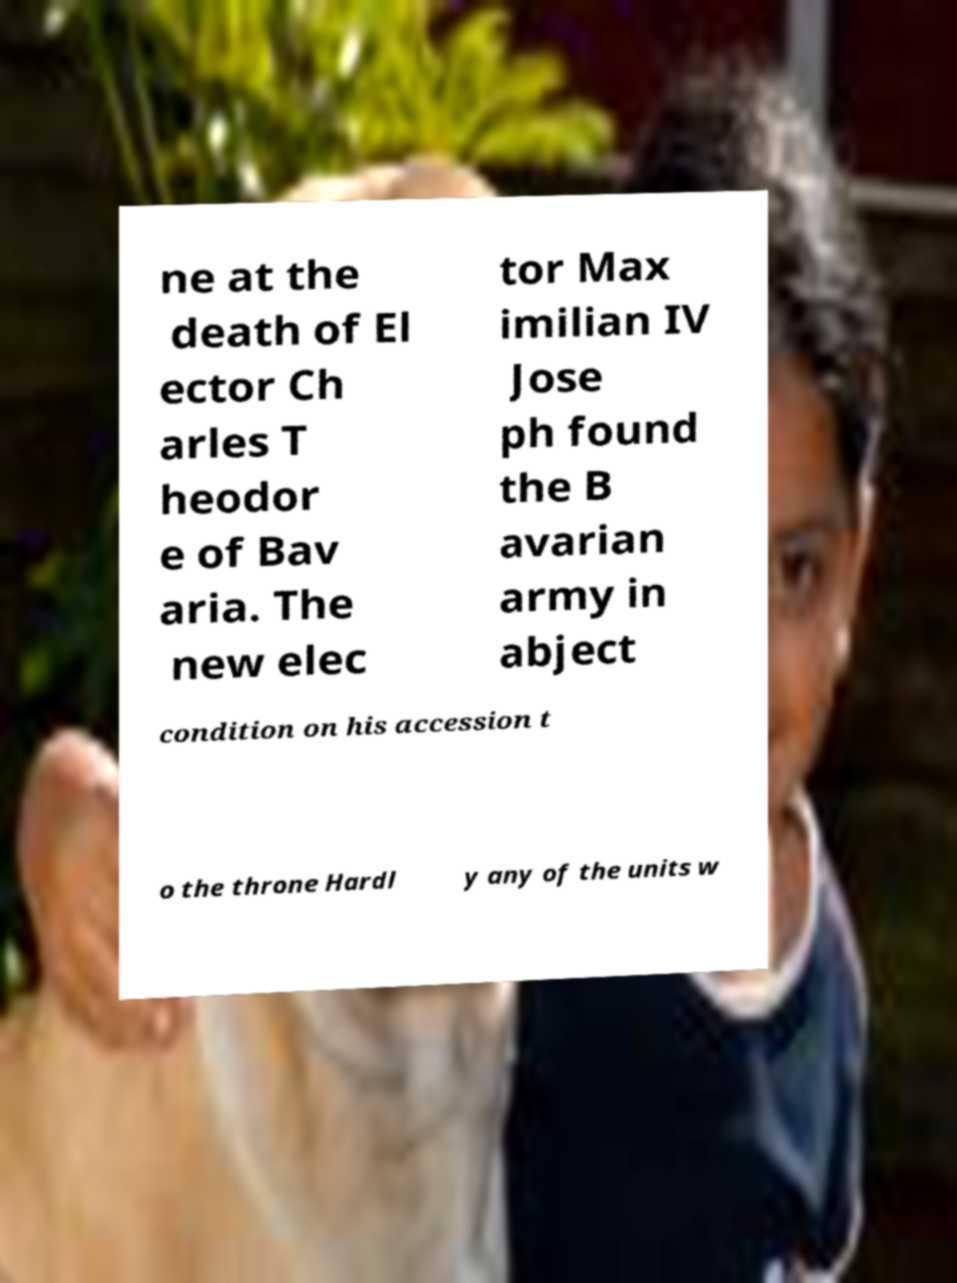Could you extract and type out the text from this image? ne at the death of El ector Ch arles T heodor e of Bav aria. The new elec tor Max imilian IV Jose ph found the B avarian army in abject condition on his accession t o the throne Hardl y any of the units w 